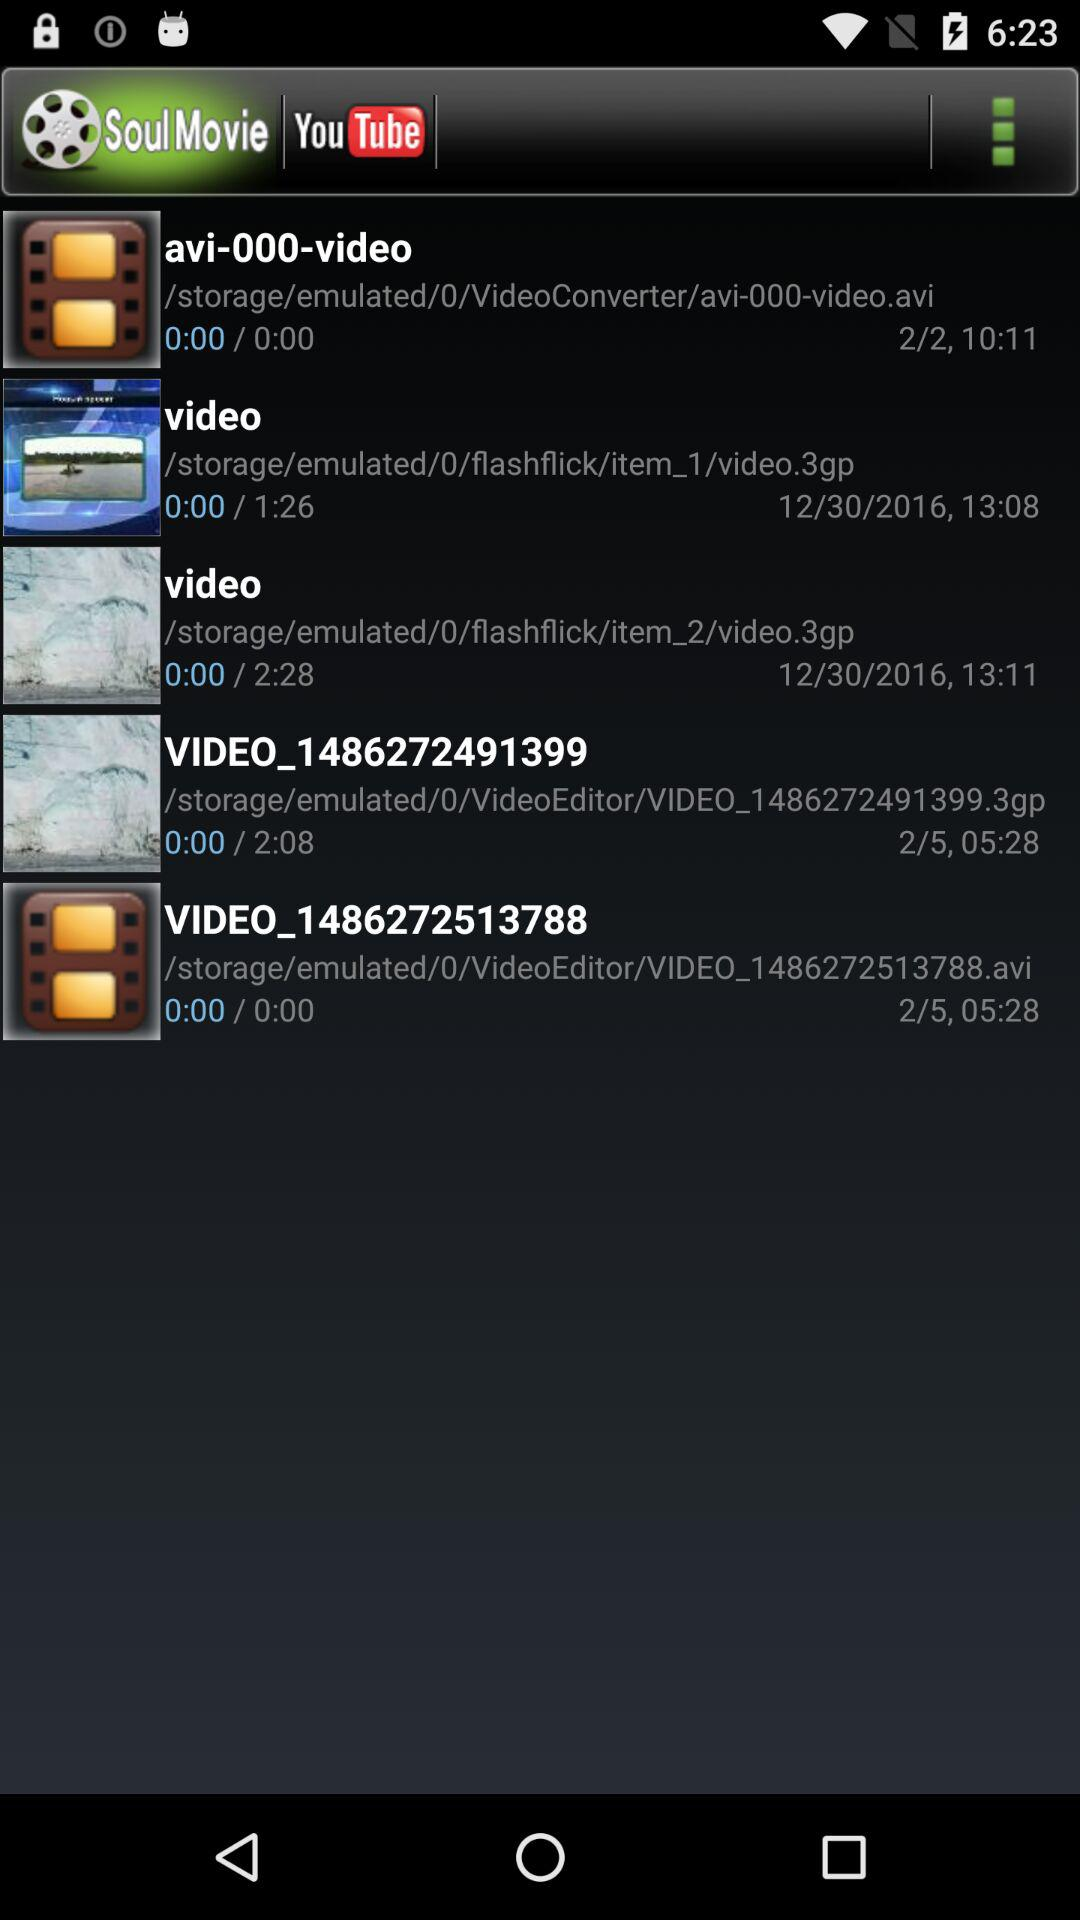What is the duration of "VIDEO_1486272513788"? The duration is 0 seconds. 